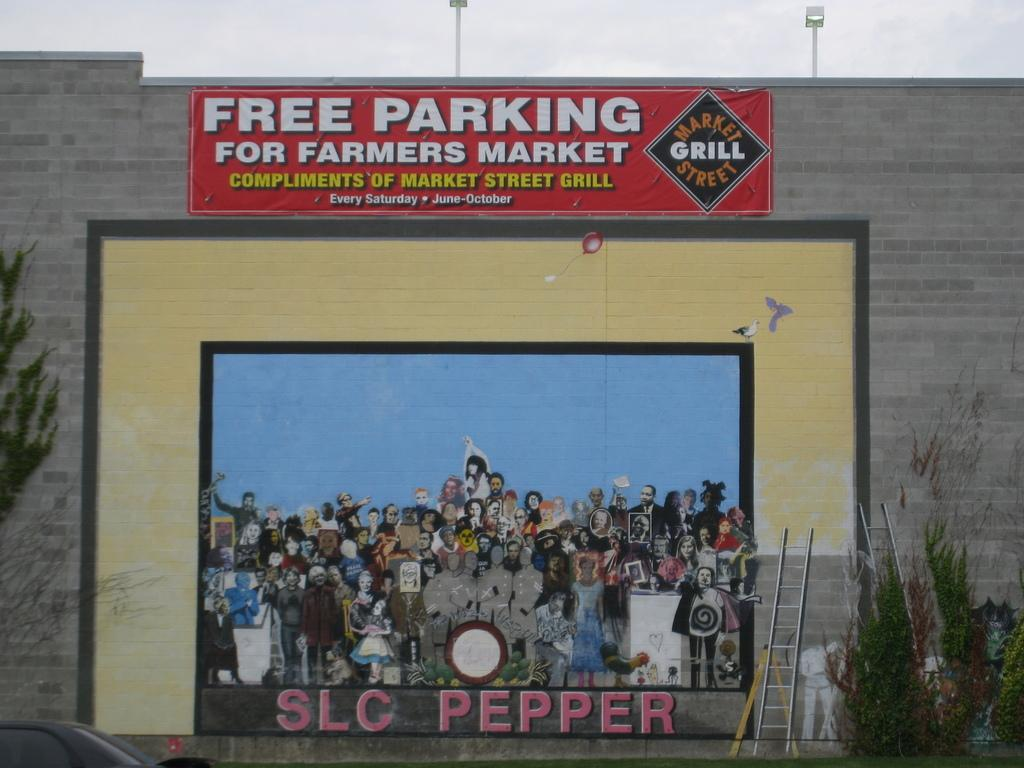<image>
Give a short and clear explanation of the subsequent image. Sign saying Free parking for the farmer's market. 